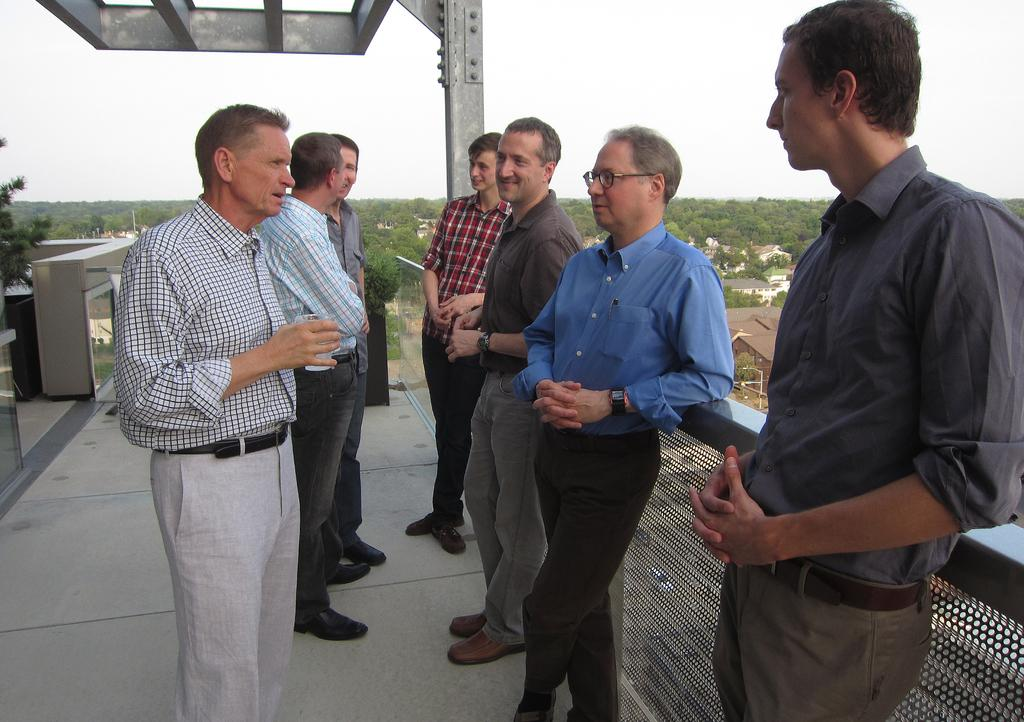Who or what is present in the image? There are people in the image. What can be seen in the foreground of the image? There is a fence in the image. What is visible in the background of the image? There are trees and houses in the background of the image. What type of boot is being used to extinguish the flame in the image? There is no boot or flame present in the image. 